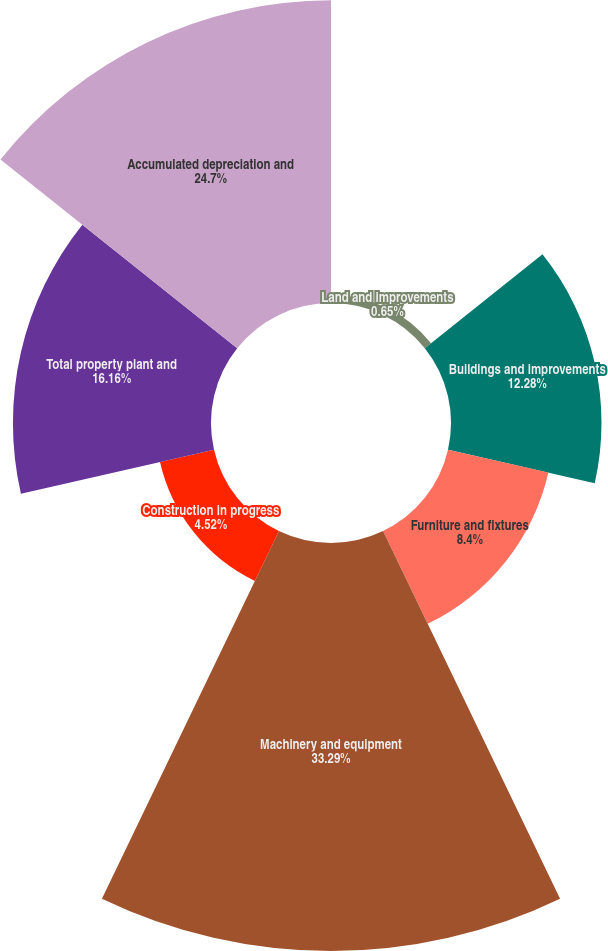Convert chart to OTSL. <chart><loc_0><loc_0><loc_500><loc_500><pie_chart><fcel>Land and improvements<fcel>Buildings and improvements<fcel>Furniture and fixtures<fcel>Machinery and equipment<fcel>Construction in progress<fcel>Total property plant and<fcel>Accumulated depreciation and<nl><fcel>0.65%<fcel>12.28%<fcel>8.4%<fcel>33.29%<fcel>4.52%<fcel>16.16%<fcel>24.7%<nl></chart> 